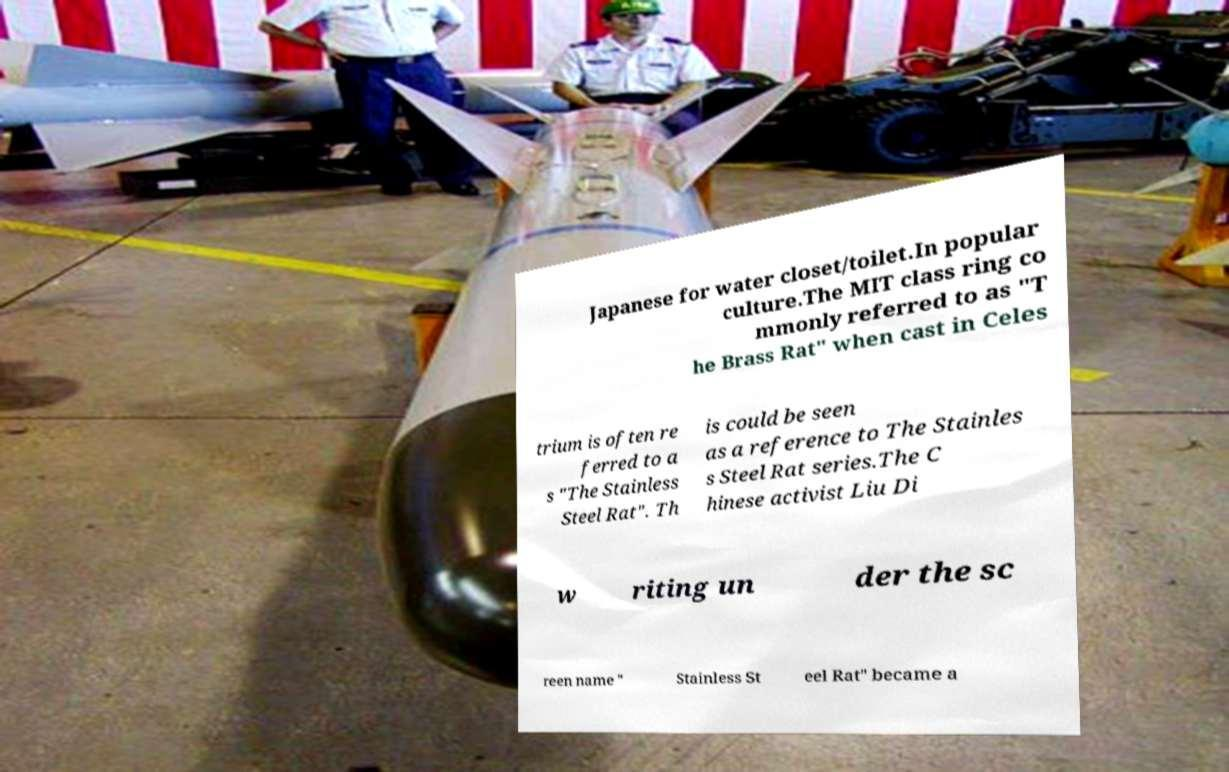I need the written content from this picture converted into text. Can you do that? Japanese for water closet/toilet.In popular culture.The MIT class ring co mmonly referred to as "T he Brass Rat" when cast in Celes trium is often re ferred to a s "The Stainless Steel Rat". Th is could be seen as a reference to The Stainles s Steel Rat series.The C hinese activist Liu Di w riting un der the sc reen name " Stainless St eel Rat" became a 